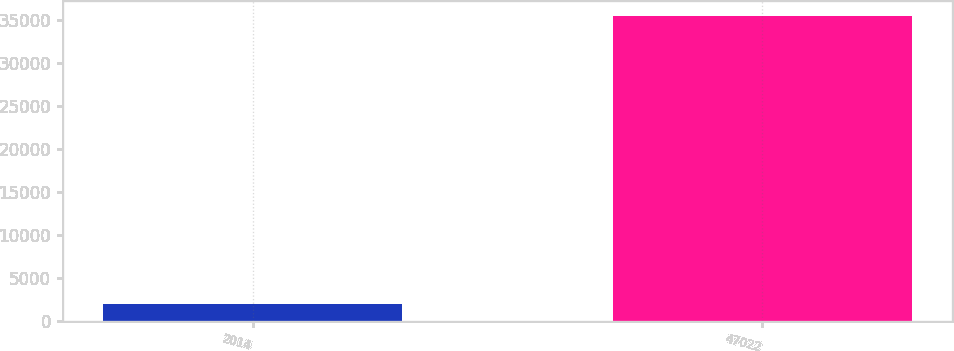Convert chart to OTSL. <chart><loc_0><loc_0><loc_500><loc_500><bar_chart><fcel>2014<fcel>47022<nl><fcel>2013<fcel>35423<nl></chart> 